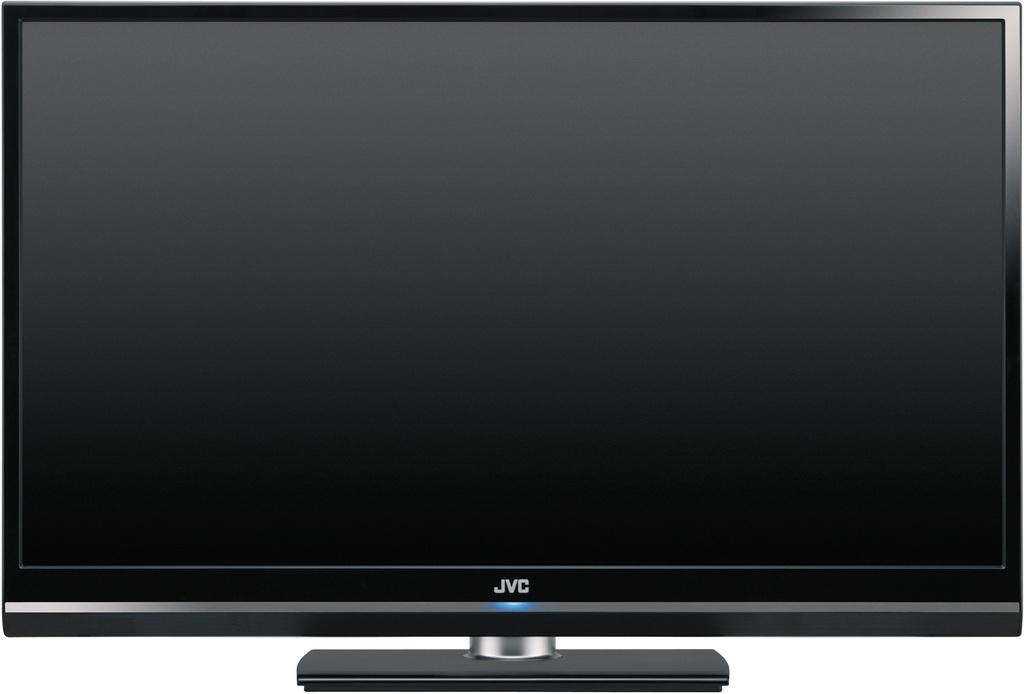<image>
Share a concise interpretation of the image provided. A JVC monitor is displayed and the screen is blank. 